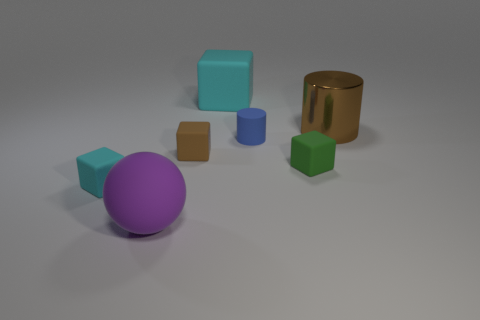The blue object that is the same material as the brown cube is what shape? The blue object sharing the same matte finish as the brown cube is a cylinder. Its slender, curved shape stands in contrast to the angular form of the cubes and the roundness of the sphere in the image. 